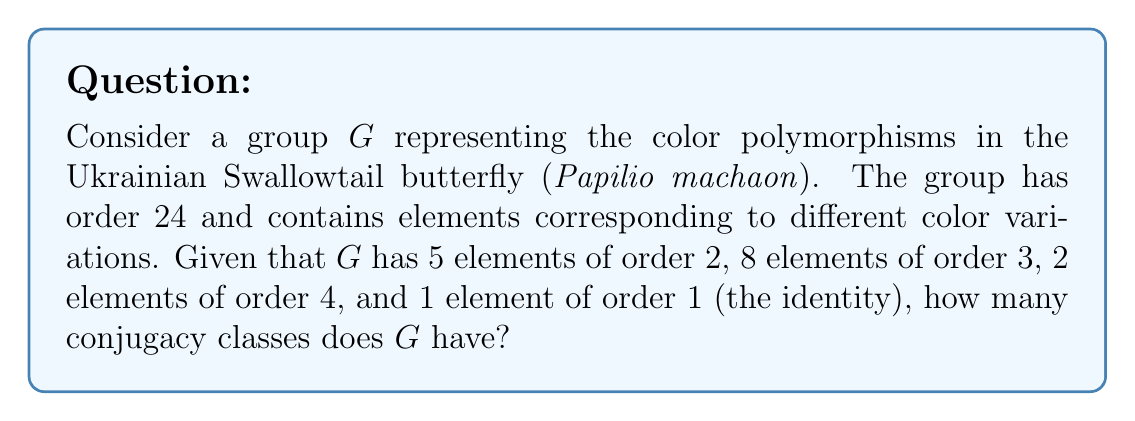Could you help me with this problem? To solve this problem, we'll use the following steps:

1) First, recall that elements in the same conjugacy class have the same order. This means we can group the elements by their orders.

2) We're given the following information about the elements in $G$:
   - 5 elements of order 2
   - 8 elements of order 3
   - 2 elements of order 4
   - 1 element of order 1 (the identity)

3) The identity element always forms its own conjugacy class. So we have 1 conjugacy class here.

4) For the elements of order 2:
   - In a group of order 24, elements of order 2 can form conjugacy classes of size 1, 3, or 6.
   - With 5 elements, the only possible combination is one class of size 3 and one class of size 2.
   So we have 2 conjugacy classes here.

5) For the elements of order 3:
   - In a group of order 24, elements of order 3 can form conjugacy classes of size 4 or 8.
   - With 8 elements, we must have one conjugacy class of size 8.
   So we have 1 conjugacy class here.

6) For the elements of order 4:
   - In a group of order 24, elements of order 4 can form conjugacy classes of size 2 or 6.
   - With 2 elements, we must have one conjugacy class of size 2.
   So we have 1 conjugacy class here.

7) Adding up all the conjugacy classes:
   1 (identity) + 2 (order 2) + 1 (order 3) + 1 (order 4) = 5

Therefore, the group $G$ has 5 conjugacy classes.
Answer: 5 conjugacy classes 